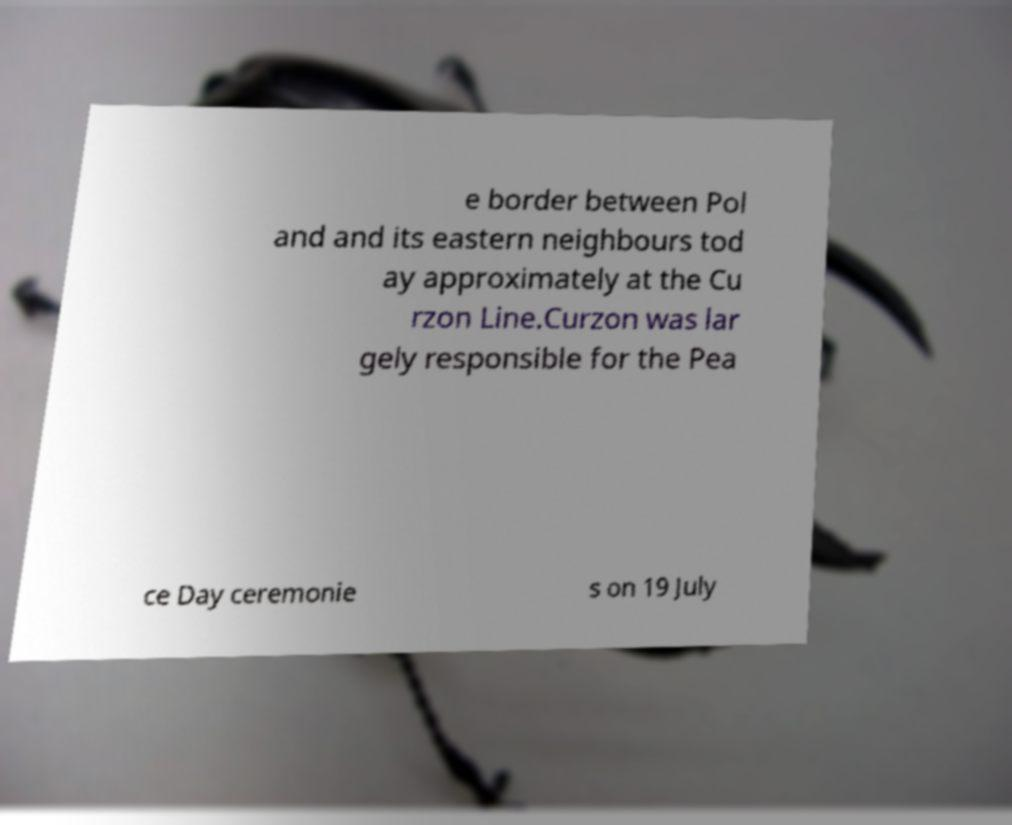Please identify and transcribe the text found in this image. e border between Pol and and its eastern neighbours tod ay approximately at the Cu rzon Line.Curzon was lar gely responsible for the Pea ce Day ceremonie s on 19 July 